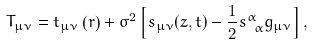<formula> <loc_0><loc_0><loc_500><loc_500>T _ { \mu \nu } = t _ { \mu \nu } \left ( r \right ) + \sigma ^ { 2 } \left [ s _ { \mu \nu } ( z , t ) - \frac { 1 } { 2 } s ^ { \alpha } _ { \ \alpha } g _ { \mu \nu } \right ] ,</formula> 